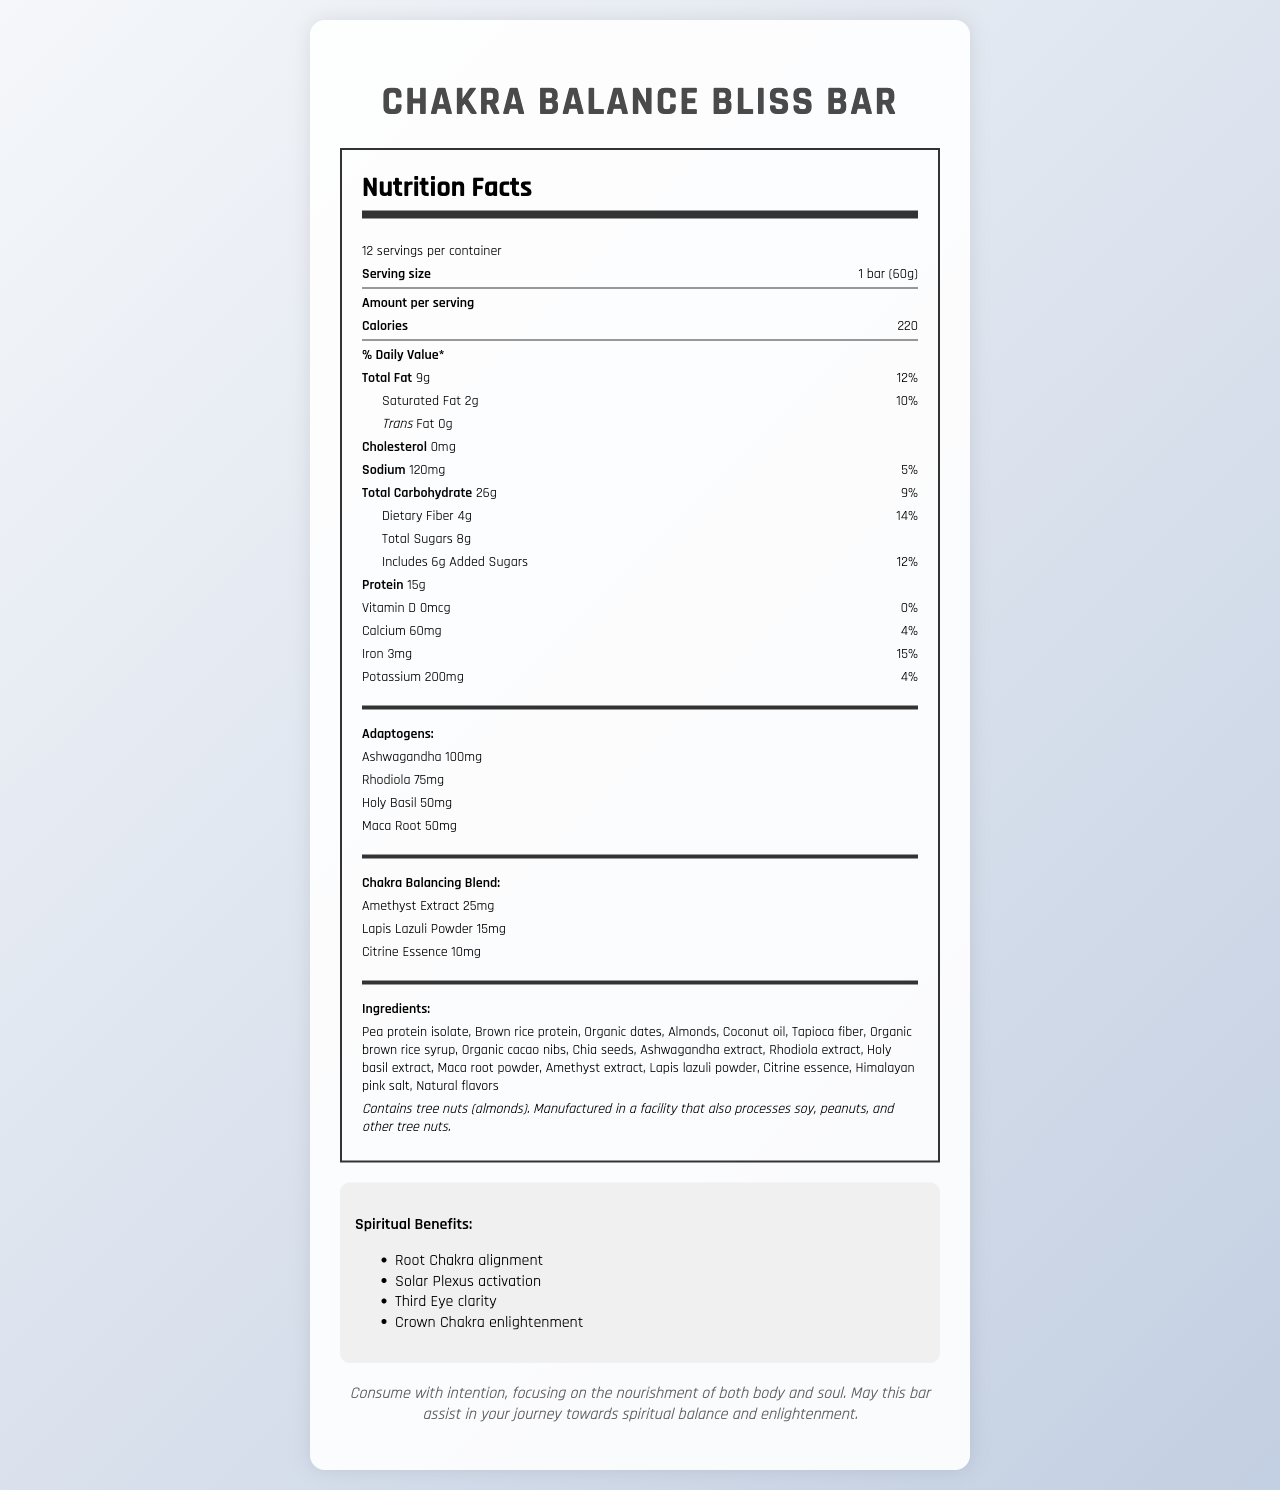what is the serving size of the Chakra Balance Bliss Bar? The serving size is clearly mentioned under the nutritional information header: "Serving size 1 bar (60g)".
Answer: 1 bar (60g) how many calories are in one serving of the bar? The number of calories per serving is listed under the nutritional information as 220 calories.
Answer: 220 what is the amount of protein in one bar? The protein content is stated in the nutritional facts section as 15g per serving.
Answer: 15g what are the amounts of ashwagandha and rhodiola present in the bar? The amounts of these adaptogens are listed under the "Adaptogens" section.
Answer: Ashwagandha: 100mg, Rhodiola: 75mg what spiritual benefits does consuming this bar provide? The spiritual benefits are listed in the "Spiritual Benefits" section.
Answer: Root Chakra alignment, Solar Plexus activation, Third Eye clarity, Crown Chakra enlightenment which of the following ingredients is NOT listed in the Chakra Balance Bliss Bar? A. Chia seeds B. Gluten C. Almonds D. Coconut oil The ingredients list in the document includes chia seeds, almonds, coconut oil, but not gluten.
Answer: B how much dietary fiber is in one bar and what percentage of daily value does it represent? A. 2g, 5% B. 4g, 14% C. 4g, 10% D. 6g, 20% Dietary fiber is listed as 4g per serving, representing 14% of the daily value.
Answer: B is there any cholesterol in the Chakra Balance Bliss Bar? The document indicates "Cholesterol 0mg".
Answer: No based on the document, how many servings are in one container? The document mentions 12 servings per container under the nutritional facts.
Answer: 12 does this bar contain any tree nuts? The allergen information states that the product contains tree nuts (almonds).
Answer: Yes summarize the main idea of the document. The document presents detailed information about the nutritional content, special ingredients, spiritual benefits, and suggested mindful consumption of the Chakra Balance Bliss Bar.
Answer: The Chakra Balance Bliss Bar is a plant-based protein bar infused with adaptogens and a chakra balancing blend, designed to provide both nutritional and spiritual benefits. It lists detailed nutrition facts, ingredients, spiritual benefits, and a mindfulness statement to enhance consumption with intention. how much added sugar is included in this bar? The nutritional facts reveal that the bar includes 6g of added sugars.
Answer: 6g what are the main categories of nutrients listed in the nutrition facts? These categories are listed in the nutrition facts section, providing comprehensive nutritional information per serving.
Answer: Total Fat, Saturated Fat, Trans Fat, Cholesterol, Sodium, Total Carbohydrate, Dietary Fiber, Total Sugars, Added Sugars, Protein, Vitamin D, Calcium, Iron, Potassium how does this bar aid in spiritual practices? A. Provides energy B. Aligns the chakras C. Contains high protein content D. Reduces stress The document indicates that the bar is infused with ingredients beneficial for balancing and aligning chakras, thus aiding in spiritual practices.
Answer: B how much sodium is in one bar? The nutritional section shows the sodium content as 120mg per serving.
Answer: 120mg how should one consume this bar according to the mindfulness statement? The mindfulness statement suggests to consume the bar with intention and awareness, focusing on the nourishment of both body and soul.
Answer: Consume with intention, focusing on the nourishment of both body and soul. how much iron is in one bar and what percentage of daily value does it represent? The nutrition facts indicate that the iron content is 3mg per serving, which is 15% of the daily value.
Answer: 3mg, 15% does the document provide the manufacturing location of the bar? The document includes ingredient and allergen information, but does not specify the manufacturing location.
Answer: Not enough information 